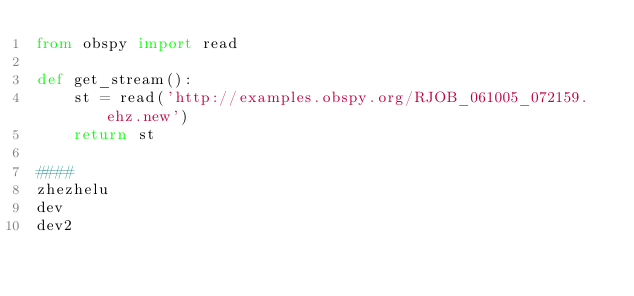<code> <loc_0><loc_0><loc_500><loc_500><_Python_>from obspy import read

def get_stream():
    st = read('http://examples.obspy.org/RJOB_061005_072159.ehz.new')
    return st

####
zhezhelu
dev
dev2</code> 